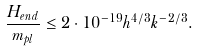<formula> <loc_0><loc_0><loc_500><loc_500>\frac { H _ { e n d } } { m _ { p l } } \leq 2 \cdot 1 0 ^ { - 1 9 } h ^ { 4 / 3 } k ^ { - 2 / 3 } .</formula> 